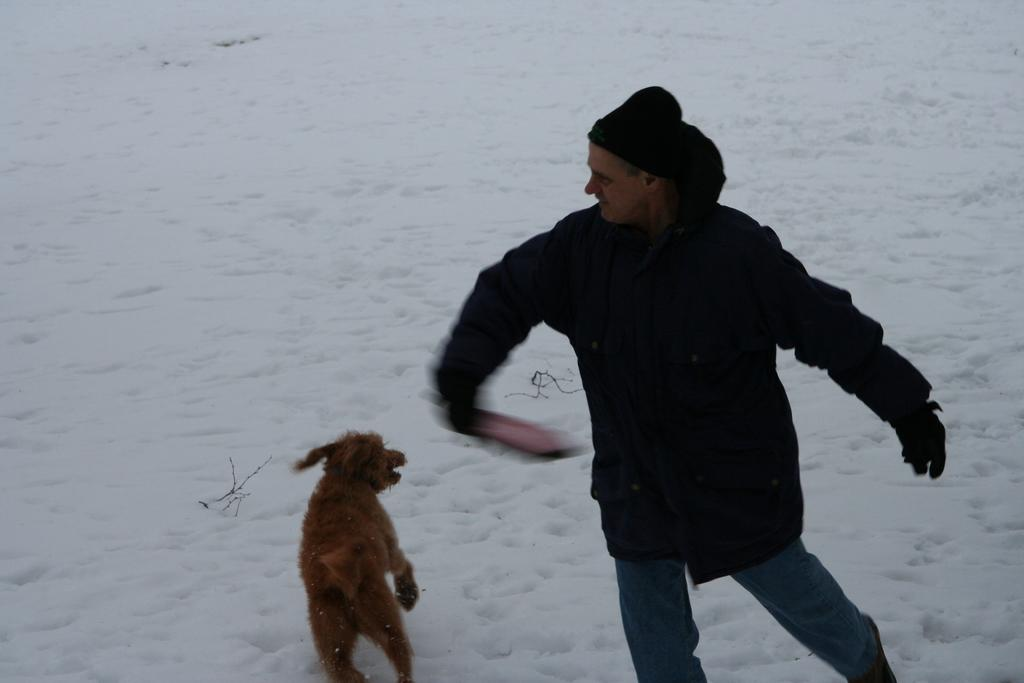Who is present in the image? There is a man in the image. What other living creature is in the image? There is a dog in the image. Where are the man and the dog located? They are on snow land. What is the man wearing? The man is wearing a black jacket. What object is the man holding? The man is holding a Frisbee in his hand. What type of bird is sitting on the van in the image? There is no van or bird present in the image. 